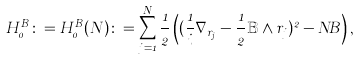<formula> <loc_0><loc_0><loc_500><loc_500>H _ { 0 } ^ { B } \colon = H _ { 0 } ^ { B } ( N ) \colon = \sum _ { j = 1 } ^ { N } \frac { 1 } { 2 } \left ( ( \frac { 1 } { i } \nabla _ { r _ { j } } - \frac { 1 } { 2 } \mathbb { B } \wedge r _ { j } ) ^ { 2 } - N B \right ) ,</formula> 